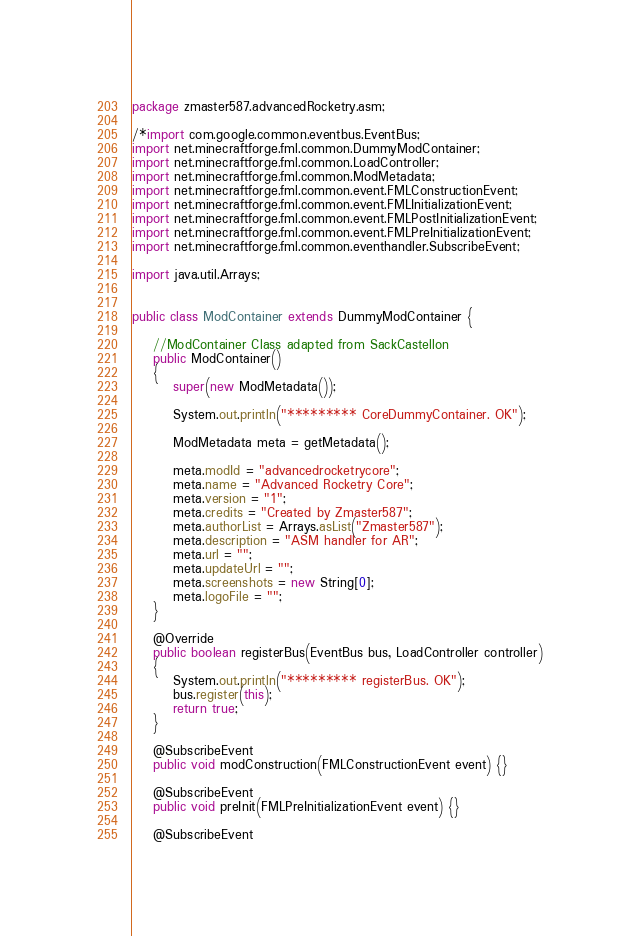Convert code to text. <code><loc_0><loc_0><loc_500><loc_500><_Java_>package zmaster587.advancedRocketry.asm;

/*import com.google.common.eventbus.EventBus;
import net.minecraftforge.fml.common.DummyModContainer;
import net.minecraftforge.fml.common.LoadController;
import net.minecraftforge.fml.common.ModMetadata;
import net.minecraftforge.fml.common.event.FMLConstructionEvent;
import net.minecraftforge.fml.common.event.FMLInitializationEvent;
import net.minecraftforge.fml.common.event.FMLPostInitializationEvent;
import net.minecraftforge.fml.common.event.FMLPreInitializationEvent;
import net.minecraftforge.fml.common.eventhandler.SubscribeEvent;

import java.util.Arrays;


public class ModContainer extends DummyModContainer {
	
	//ModContainer Class adapted from SackCastellon
	public ModContainer()
	{		
		super(new ModMetadata());
		
		System.out.println("********* CoreDummyContainer. OK");
		
		ModMetadata meta = getMetadata();
		
		meta.modId = "advancedrocketrycore";
		meta.name = "Advanced Rocketry Core";
		meta.version = "1";
		meta.credits = "Created by Zmaster587";
		meta.authorList = Arrays.asList("Zmaster587");
		meta.description = "ASM handler for AR";
		meta.url = "";
		meta.updateUrl = "";
		meta.screenshots = new String[0];
		meta.logoFile = "";
	}

	@Override
	public boolean registerBus(EventBus bus, LoadController controller)
	{
		System.out.println("********* registerBus. OK");
		bus.register(this);
		return true;
	}
	
	@SubscribeEvent
	public void modConstruction(FMLConstructionEvent event) {}
	
	@SubscribeEvent
	public void preInit(FMLPreInitializationEvent event) {}
	
	@SubscribeEvent</code> 